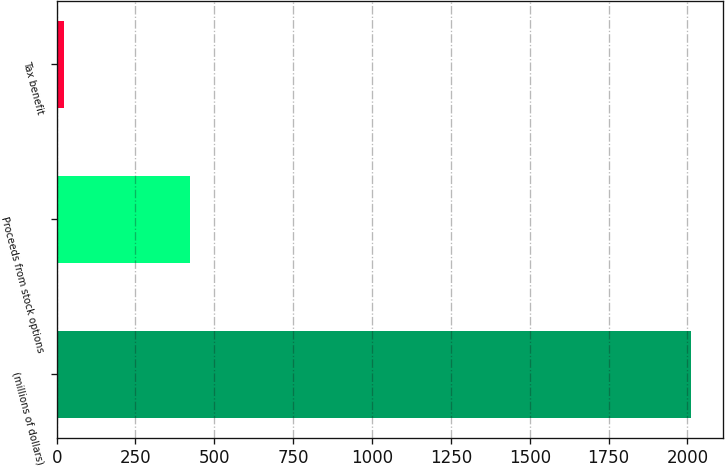<chart> <loc_0><loc_0><loc_500><loc_500><bar_chart><fcel>(millions of dollars)<fcel>Proceeds from stock options<fcel>Tax benefit<nl><fcel>2011<fcel>421.72<fcel>24.4<nl></chart> 